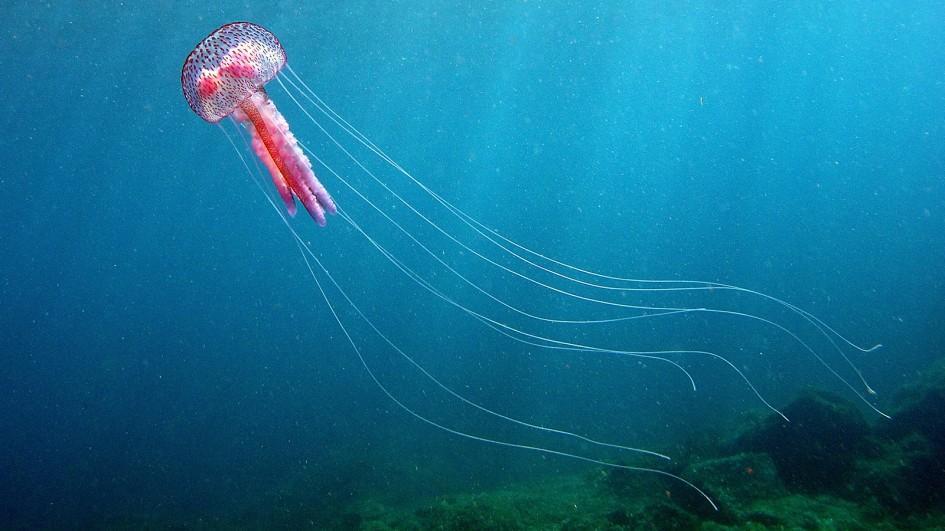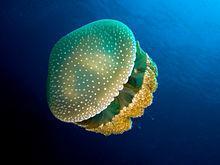The first image is the image on the left, the second image is the image on the right. Examine the images to the left and right. Is the description "At least one of the jellyfish clearly has white spots all over the bell." accurate? Answer yes or no. Yes. 